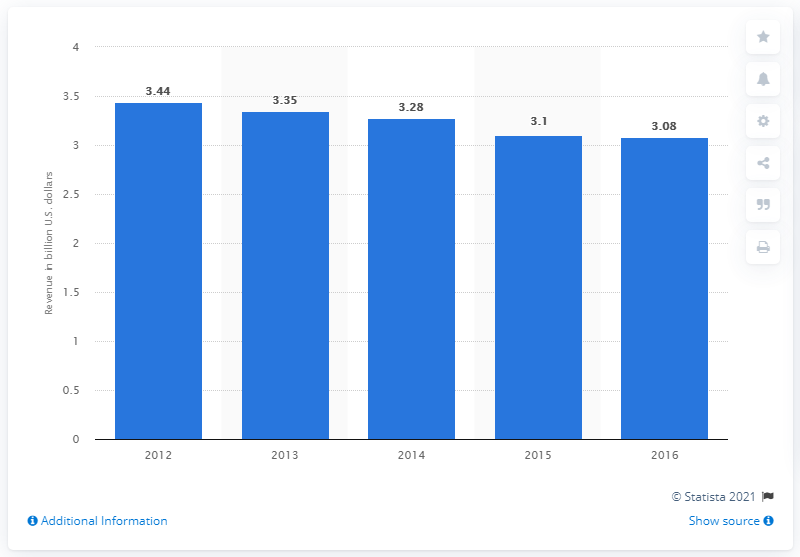Identify some key points in this picture. Time Inc. generated approximately 3.35 billion dollars in revenue in 2013. 